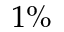<formula> <loc_0><loc_0><loc_500><loc_500>1 \%</formula> 